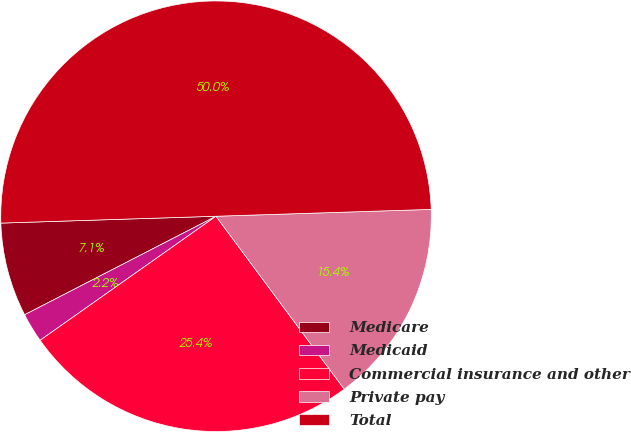<chart> <loc_0><loc_0><loc_500><loc_500><pie_chart><fcel>Medicare<fcel>Medicaid<fcel>Commercial insurance and other<fcel>Private pay<fcel>Total<nl><fcel>7.06%<fcel>2.21%<fcel>25.38%<fcel>15.35%<fcel>50.0%<nl></chart> 